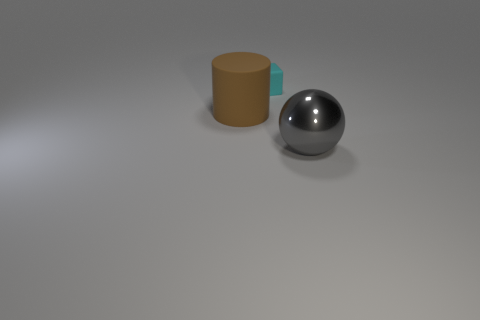Add 2 large red rubber cylinders. How many objects exist? 5 Add 2 brown cylinders. How many brown cylinders are left? 3 Add 2 red metal objects. How many red metal objects exist? 2 Subtract 0 green cylinders. How many objects are left? 3 Subtract all spheres. How many objects are left? 2 Subtract all cyan cylinders. Subtract all red cubes. How many cylinders are left? 1 Subtract all cyan rubber cubes. Subtract all small cyan matte things. How many objects are left? 1 